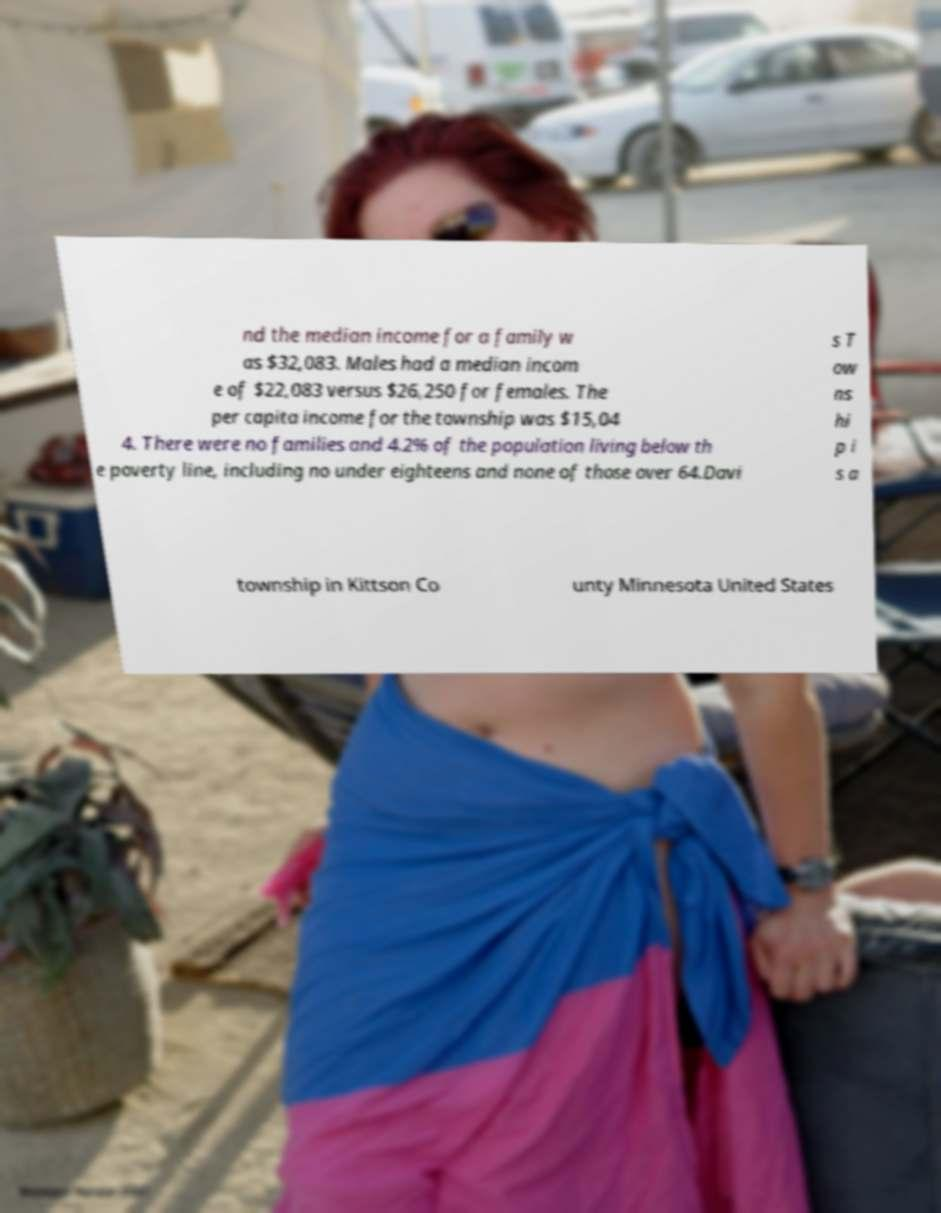Could you extract and type out the text from this image? nd the median income for a family w as $32,083. Males had a median incom e of $22,083 versus $26,250 for females. The per capita income for the township was $15,04 4. There were no families and 4.2% of the population living below th e poverty line, including no under eighteens and none of those over 64.Davi s T ow ns hi p i s a township in Kittson Co unty Minnesota United States 